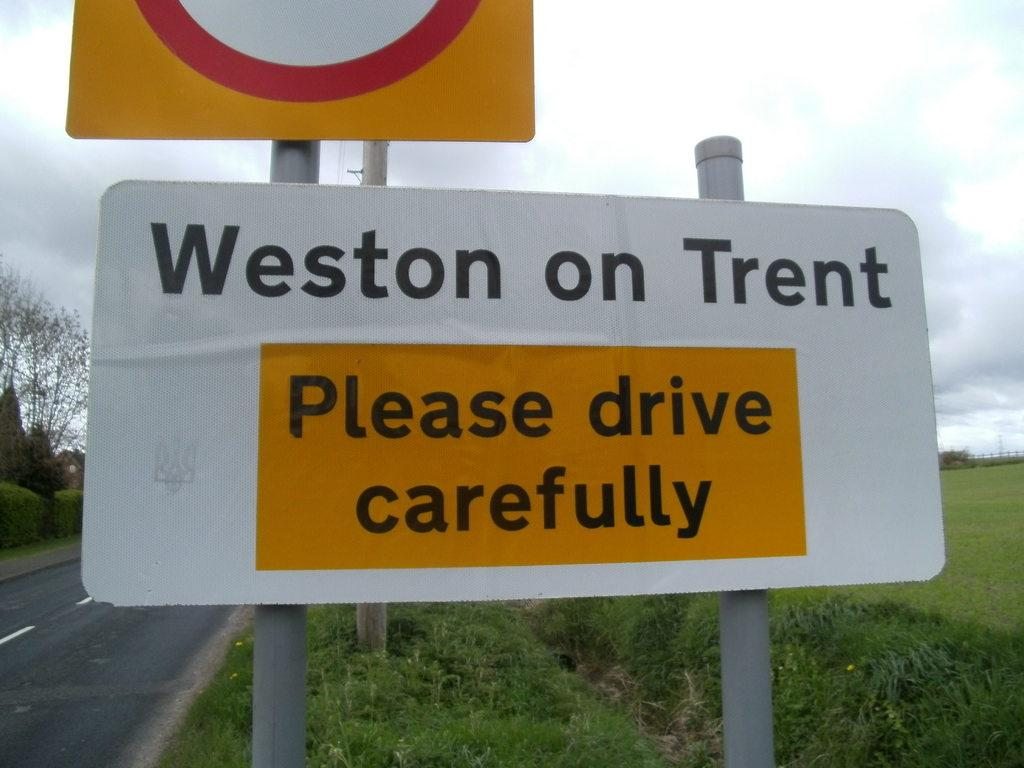<image>
Give a short and clear explanation of the subsequent image. A sign urging drivers to please drive carefully on Weston on Trent sits on the roadside. 